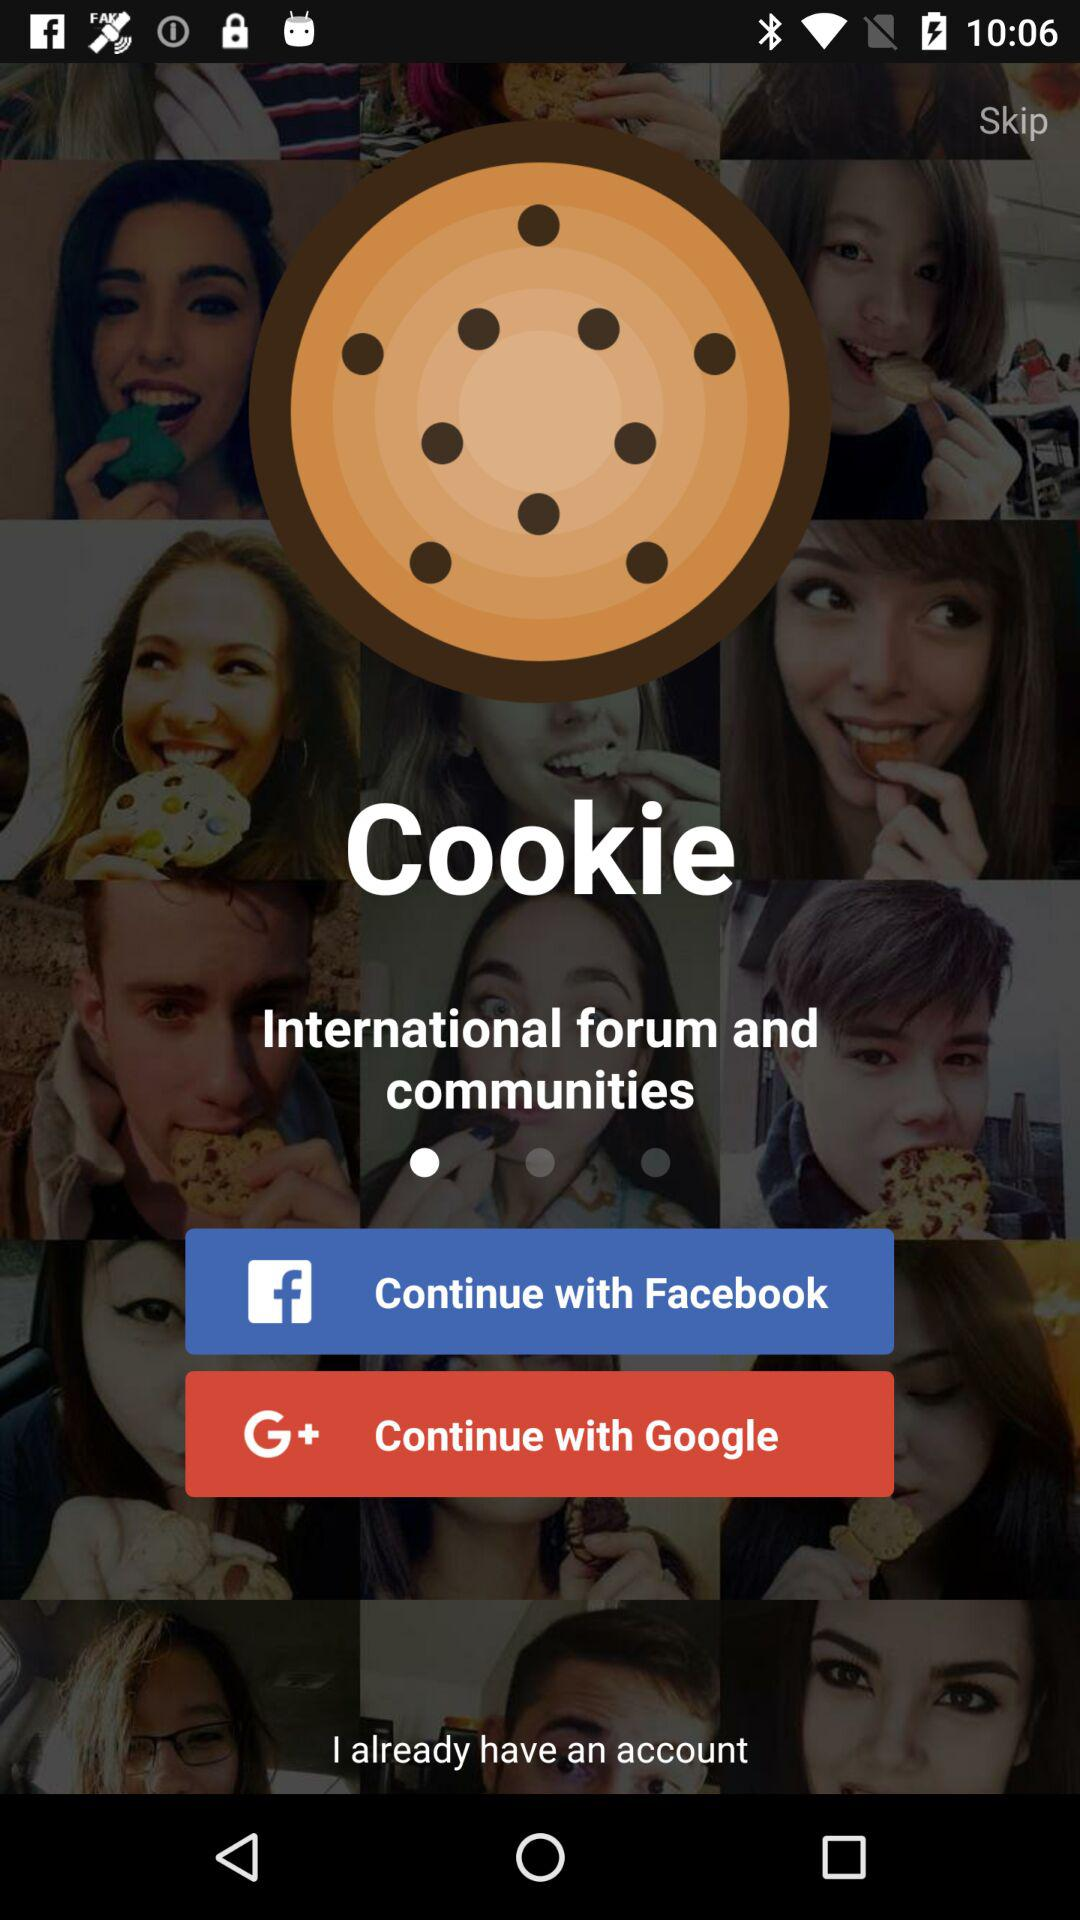What is the name of the application? The name of the application is "Cookie". 